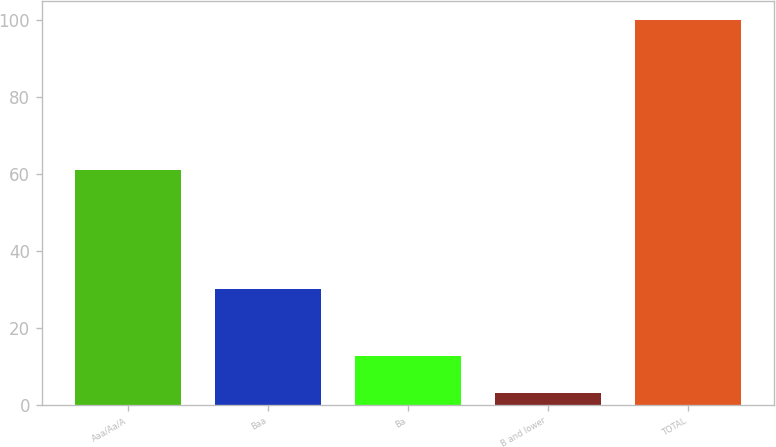<chart> <loc_0><loc_0><loc_500><loc_500><bar_chart><fcel>Aaa/Aa/A<fcel>Baa<fcel>Ba<fcel>B and lower<fcel>TOTAL<nl><fcel>61<fcel>30<fcel>12.7<fcel>3<fcel>100<nl></chart> 